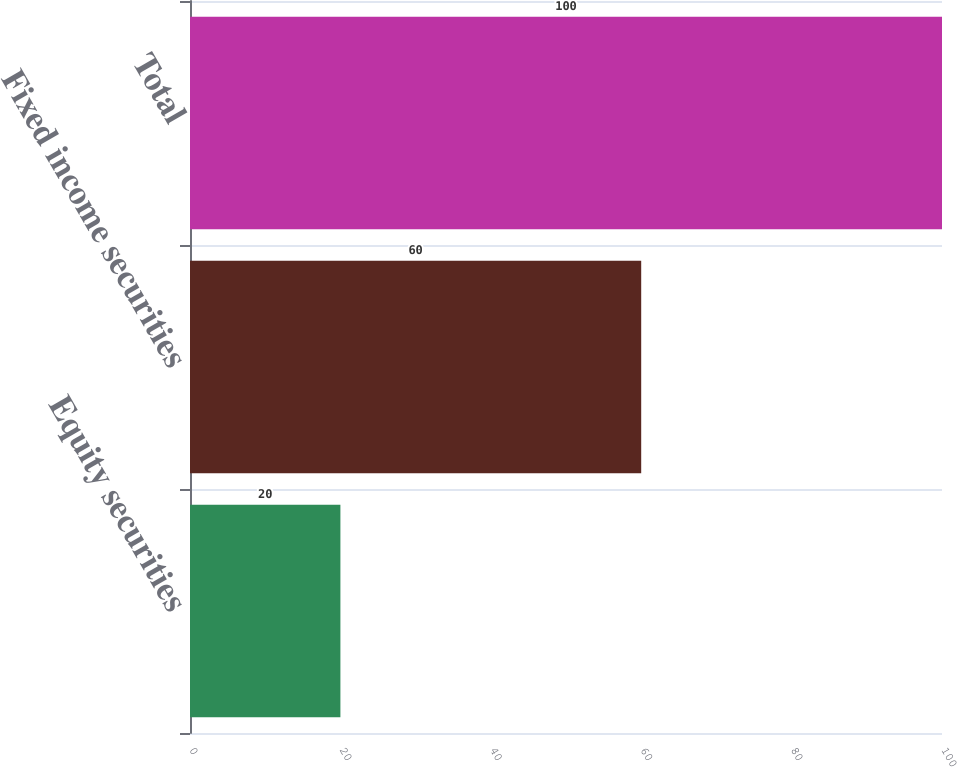Convert chart to OTSL. <chart><loc_0><loc_0><loc_500><loc_500><bar_chart><fcel>Equity securities<fcel>Fixed income securities<fcel>Total<nl><fcel>20<fcel>60<fcel>100<nl></chart> 